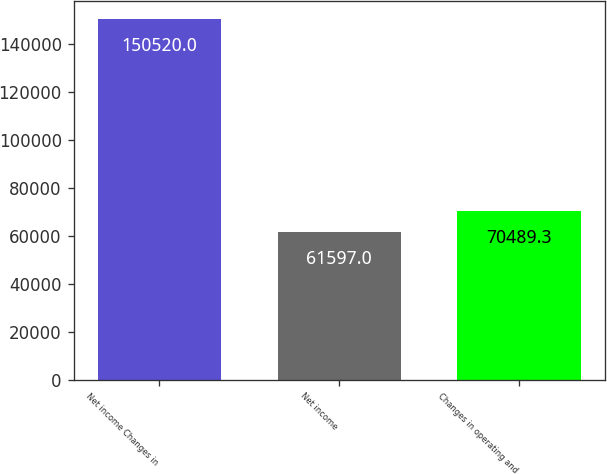<chart> <loc_0><loc_0><loc_500><loc_500><bar_chart><fcel>Net income Changes in<fcel>Net income<fcel>Changes in operating and<nl><fcel>150520<fcel>61597<fcel>70489.3<nl></chart> 